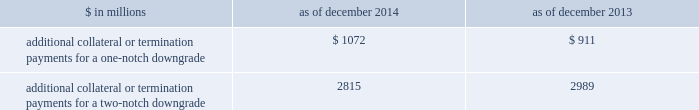Management 2019s discussion and analysis we believe our credit ratings are primarily based on the credit rating agencies 2019 assessment of : 2030 our liquidity , market , credit and operational risk management practices ; 2030 the level and variability of our earnings ; 2030 our capital base ; 2030 our franchise , reputation and management ; 2030 our corporate governance ; and 2030 the external operating environment , including , in some cases , the assumed level of government or other systemic support .
Certain of our derivatives have been transacted under bilateral agreements with counterparties who may require us to post collateral or terminate the transactions based on changes in our credit ratings .
We assess the impact of these bilateral agreements by determining the collateral or termination payments that would occur assuming a downgrade by all rating agencies .
A downgrade by any one rating agency , depending on the agency 2019s relative ratings of us at the time of the downgrade , may have an impact which is comparable to the impact of a downgrade by all rating agencies .
We allocate a portion of our gcla to ensure we would be able to make the additional collateral or termination payments that may be required in the event of a two-notch reduction in our long-term credit ratings , as well as collateral that has not been called by counterparties , but is available to them .
The table below presents the additional collateral or termination payments related to our net derivative liabilities under bilateral agreements that could have been called at the reporting date by counterparties in the event of a one-notch and two-notch downgrade in our credit ratings. .
$ in millions 2014 2013 additional collateral or termination payments for a one-notch downgrade $ 1072 $ 911 additional collateral or termination payments for a two-notch downgrade 2815 2989 cash flows as a global financial institution , our cash flows are complex and bear little relation to our net earnings and net assets .
Consequently , we believe that traditional cash flow analysis is less meaningful in evaluating our liquidity position than the liquidity and asset-liability management policies described above .
Cash flow analysis may , however , be helpful in highlighting certain macro trends and strategic initiatives in our businesses .
Year ended december 2014 .
Our cash and cash equivalents decreased by $ 3.53 billion to $ 57.60 billion at the end of 2014 .
We used $ 22.53 billion in net cash for operating and investing activities , which reflects an initiative to reduce our balance sheet , and the funding of loans receivable .
We generated $ 19.00 billion in net cash from financing activities from an increase in bank deposits and net proceeds from issuances of unsecured long-term borrowings , partially offset by repurchases of common stock .
Year ended december 2013 .
Our cash and cash equivalents decreased by $ 11.54 billion to $ 61.13 billion at the end of 2013 .
We generated $ 4.54 billion in net cash from operating activities .
We used net cash of $ 16.08 billion for investing and financing activities , primarily to fund loans receivable and repurchases of common stock .
Year ended december 2012 .
Our cash and cash equivalents increased by $ 16.66 billion to $ 72.67 billion at the end of 2012 .
We generated $ 9.14 billion in net cash from operating and investing activities .
We generated $ 7.52 billion in net cash from financing activities from an increase in bank deposits , partially offset by net repayments of unsecured and secured long-term borrowings .
78 goldman sachs 2014 annual report .
What is the difference in the required additional collateral or termination payments for a two-notch downgrade and additional collateral or termination payments for a one-notch downgrade in millions in 2013? 
Computations: (2989 - 911)
Answer: 2078.0. Management 2019s discussion and analysis we believe our credit ratings are primarily based on the credit rating agencies 2019 assessment of : 2030 our liquidity , market , credit and operational risk management practices ; 2030 the level and variability of our earnings ; 2030 our capital base ; 2030 our franchise , reputation and management ; 2030 our corporate governance ; and 2030 the external operating environment , including , in some cases , the assumed level of government or other systemic support .
Certain of our derivatives have been transacted under bilateral agreements with counterparties who may require us to post collateral or terminate the transactions based on changes in our credit ratings .
We assess the impact of these bilateral agreements by determining the collateral or termination payments that would occur assuming a downgrade by all rating agencies .
A downgrade by any one rating agency , depending on the agency 2019s relative ratings of us at the time of the downgrade , may have an impact which is comparable to the impact of a downgrade by all rating agencies .
We allocate a portion of our gcla to ensure we would be able to make the additional collateral or termination payments that may be required in the event of a two-notch reduction in our long-term credit ratings , as well as collateral that has not been called by counterparties , but is available to them .
The table below presents the additional collateral or termination payments related to our net derivative liabilities under bilateral agreements that could have been called at the reporting date by counterparties in the event of a one-notch and two-notch downgrade in our credit ratings. .
$ in millions 2014 2013 additional collateral or termination payments for a one-notch downgrade $ 1072 $ 911 additional collateral or termination payments for a two-notch downgrade 2815 2989 cash flows as a global financial institution , our cash flows are complex and bear little relation to our net earnings and net assets .
Consequently , we believe that traditional cash flow analysis is less meaningful in evaluating our liquidity position than the liquidity and asset-liability management policies described above .
Cash flow analysis may , however , be helpful in highlighting certain macro trends and strategic initiatives in our businesses .
Year ended december 2014 .
Our cash and cash equivalents decreased by $ 3.53 billion to $ 57.60 billion at the end of 2014 .
We used $ 22.53 billion in net cash for operating and investing activities , which reflects an initiative to reduce our balance sheet , and the funding of loans receivable .
We generated $ 19.00 billion in net cash from financing activities from an increase in bank deposits and net proceeds from issuances of unsecured long-term borrowings , partially offset by repurchases of common stock .
Year ended december 2013 .
Our cash and cash equivalents decreased by $ 11.54 billion to $ 61.13 billion at the end of 2013 .
We generated $ 4.54 billion in net cash from operating activities .
We used net cash of $ 16.08 billion for investing and financing activities , primarily to fund loans receivable and repurchases of common stock .
Year ended december 2012 .
Our cash and cash equivalents increased by $ 16.66 billion to $ 72.67 billion at the end of 2012 .
We generated $ 9.14 billion in net cash from operating and investing activities .
We generated $ 7.52 billion in net cash from financing activities from an increase in bank deposits , partially offset by net repayments of unsecured and secured long-term borrowings .
78 goldman sachs 2014 annual report .
What is the difference in the required additional collateral or termination payments for a two-notch downgrade and additional collateral or termination payments for a one-notch downgrade in millions in 2014? 
Computations: (2815 - 1072)
Answer: 1743.0. 